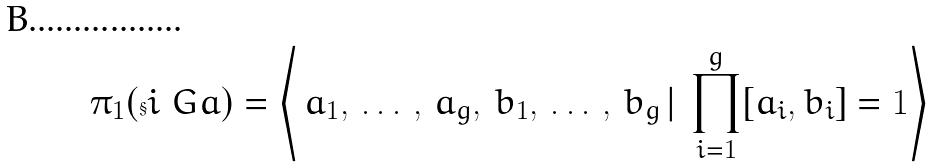<formula> <loc_0><loc_0><loc_500><loc_500>\pi _ { 1 } ( \S i _ { \ } G a ) = \left \langle \, a _ { 1 } , \, \dots \, , \, a _ { g } , \, b _ { 1 } , \, \dots \, , \, b _ { g } \, | \, \prod _ { i = 1 } ^ { g } [ a _ { i } , b _ { i } ] = 1 \right \rangle</formula> 